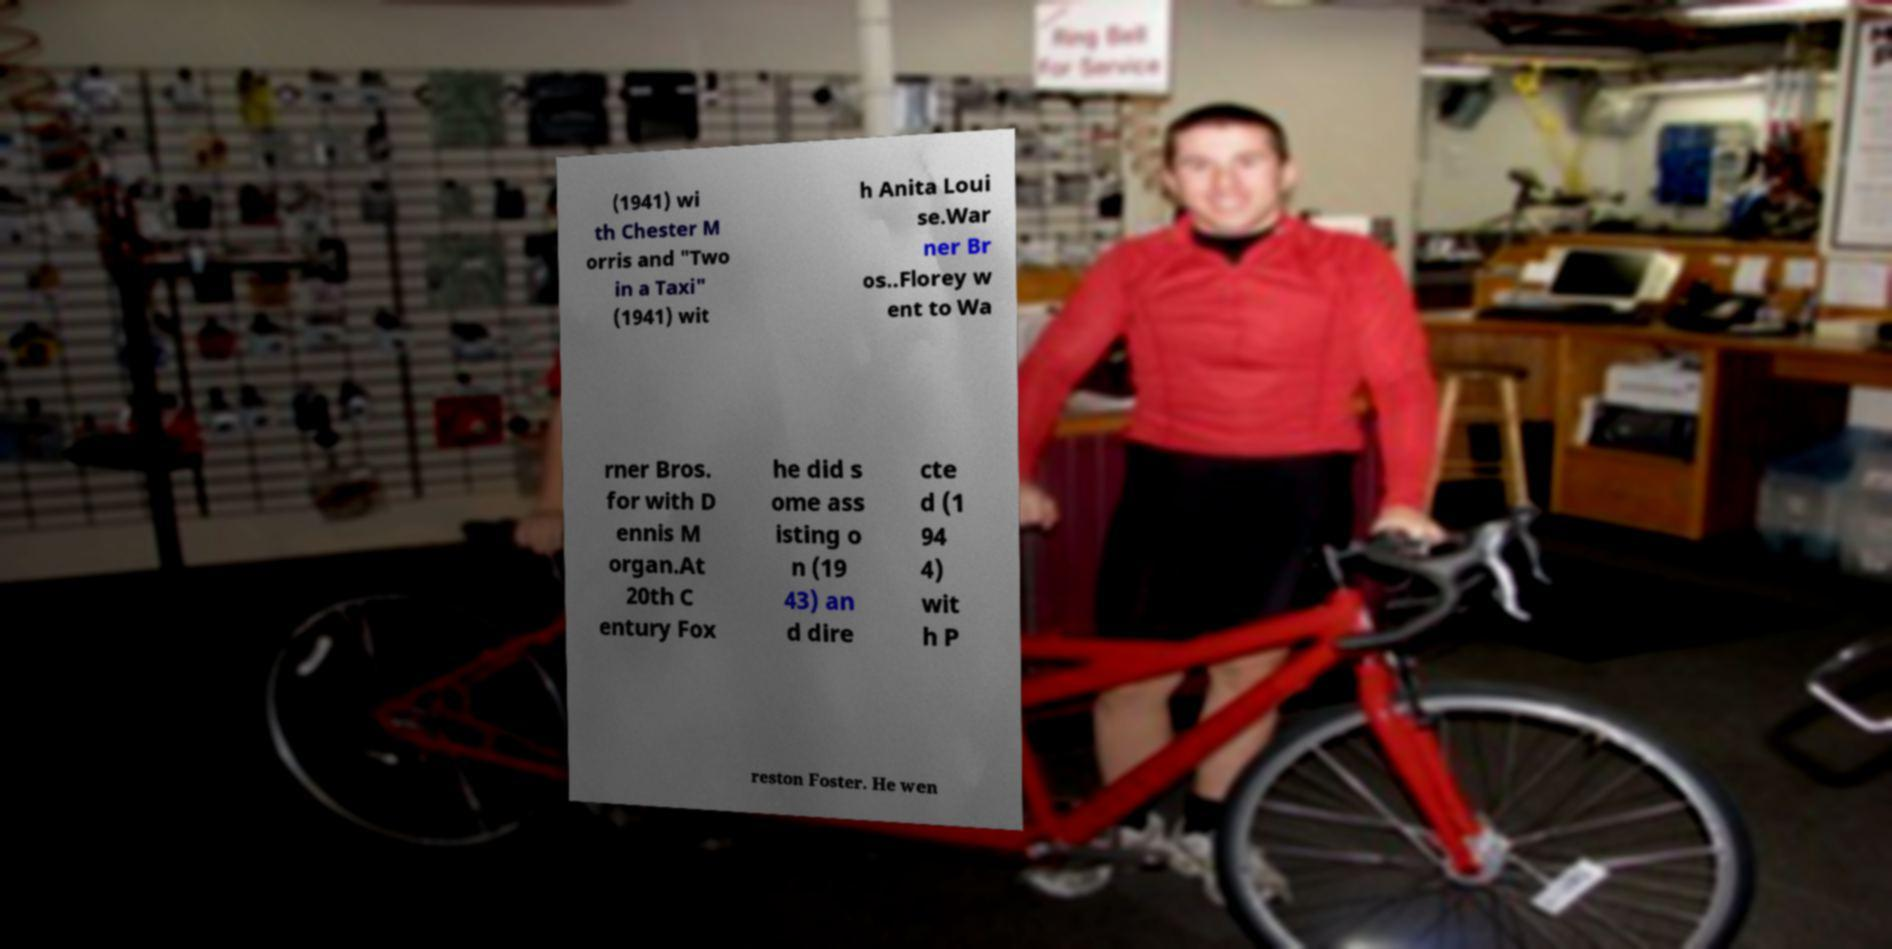Please read and relay the text visible in this image. What does it say? (1941) wi th Chester M orris and "Two in a Taxi" (1941) wit h Anita Loui se.War ner Br os..Florey w ent to Wa rner Bros. for with D ennis M organ.At 20th C entury Fox he did s ome ass isting o n (19 43) an d dire cte d (1 94 4) wit h P reston Foster. He wen 